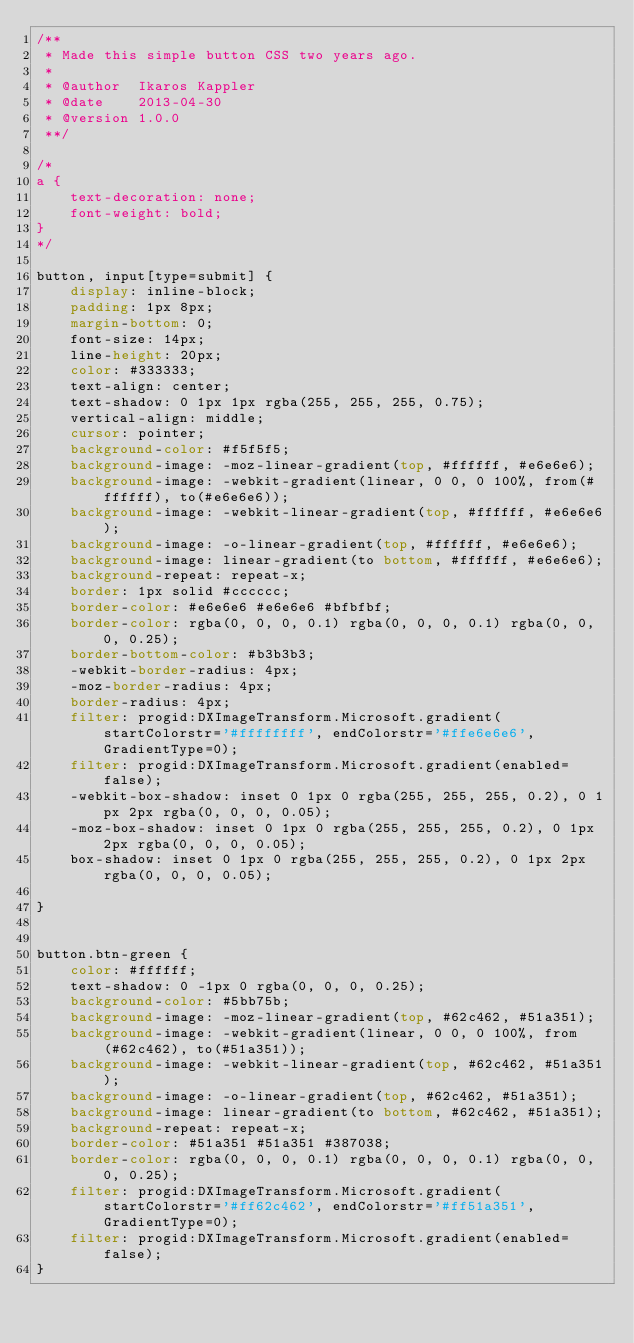<code> <loc_0><loc_0><loc_500><loc_500><_CSS_>/**
 * Made this simple button CSS two years ago.
 *
 * @author  Ikaros Kappler
 * @date    2013-04-30
 * @version 1.0.0
 **/

/*
a {
    text-decoration: none;
    font-weight: bold;
}
*/

button, input[type=submit] {
    display: inline-block;
    padding: 1px 8px;
    margin-bottom: 0;
    font-size: 14px;
    line-height: 20px;
    color: #333333;
    text-align: center;
    text-shadow: 0 1px 1px rgba(255, 255, 255, 0.75);
    vertical-align: middle;
    cursor: pointer;
    background-color: #f5f5f5;
    background-image: -moz-linear-gradient(top, #ffffff, #e6e6e6);
    background-image: -webkit-gradient(linear, 0 0, 0 100%, from(#ffffff), to(#e6e6e6));
    background-image: -webkit-linear-gradient(top, #ffffff, #e6e6e6);
    background-image: -o-linear-gradient(top, #ffffff, #e6e6e6);
    background-image: linear-gradient(to bottom, #ffffff, #e6e6e6);
    background-repeat: repeat-x;
    border: 1px solid #cccccc;
    border-color: #e6e6e6 #e6e6e6 #bfbfbf;
    border-color: rgba(0, 0, 0, 0.1) rgba(0, 0, 0, 0.1) rgba(0, 0, 0, 0.25);
    border-bottom-color: #b3b3b3;
    -webkit-border-radius: 4px;
    -moz-border-radius: 4px;
    border-radius: 4px;
    filter: progid:DXImageTransform.Microsoft.gradient(startColorstr='#ffffffff', endColorstr='#ffe6e6e6', GradientType=0);
    filter: progid:DXImageTransform.Microsoft.gradient(enabled=false);
    -webkit-box-shadow: inset 0 1px 0 rgba(255, 255, 255, 0.2), 0 1px 2px rgba(0, 0, 0, 0.05);
    -moz-box-shadow: inset 0 1px 0 rgba(255, 255, 255, 0.2), 0 1px 2px rgba(0, 0, 0, 0.05);
    box-shadow: inset 0 1px 0 rgba(255, 255, 255, 0.2), 0 1px 2px rgba(0, 0, 0, 0.05);
    
}


button.btn-green {
    color: #ffffff;
    text-shadow: 0 -1px 0 rgba(0, 0, 0, 0.25);
    background-color: #5bb75b;
    background-image: -moz-linear-gradient(top, #62c462, #51a351);
    background-image: -webkit-gradient(linear, 0 0, 0 100%, from(#62c462), to(#51a351));
    background-image: -webkit-linear-gradient(top, #62c462, #51a351);
    background-image: -o-linear-gradient(top, #62c462, #51a351);
    background-image: linear-gradient(to bottom, #62c462, #51a351);
    background-repeat: repeat-x;
    border-color: #51a351 #51a351 #387038;
    border-color: rgba(0, 0, 0, 0.1) rgba(0, 0, 0, 0.1) rgba(0, 0, 0, 0.25);
    filter: progid:DXImageTransform.Microsoft.gradient(startColorstr='#ff62c462', endColorstr='#ff51a351', GradientType=0);
    filter: progid:DXImageTransform.Microsoft.gradient(enabled=false);
}</code> 